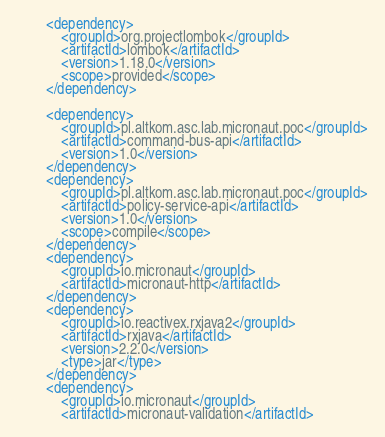Convert code to text. <code><loc_0><loc_0><loc_500><loc_500><_XML_>        <dependency>
            <groupId>org.projectlombok</groupId>
            <artifactId>lombok</artifactId>
            <version>1.18.0</version>
            <scope>provided</scope>
        </dependency>

        <dependency>
            <groupId>pl.altkom.asc.lab.micronaut.poc</groupId>
            <artifactId>command-bus-api</artifactId>
            <version>1.0</version>
        </dependency>
        <dependency>
            <groupId>pl.altkom.asc.lab.micronaut.poc</groupId>
            <artifactId>policy-service-api</artifactId>
            <version>1.0</version>
            <scope>compile</scope>
        </dependency>
        <dependency>
            <groupId>io.micronaut</groupId>
            <artifactId>micronaut-http</artifactId>
        </dependency>
        <dependency>
            <groupId>io.reactivex.rxjava2</groupId>
            <artifactId>rxjava</artifactId>
            <version>2.2.0</version>
            <type>jar</type>
        </dependency>
        <dependency>
            <groupId>io.micronaut</groupId>
            <artifactId>micronaut-validation</artifactId></code> 